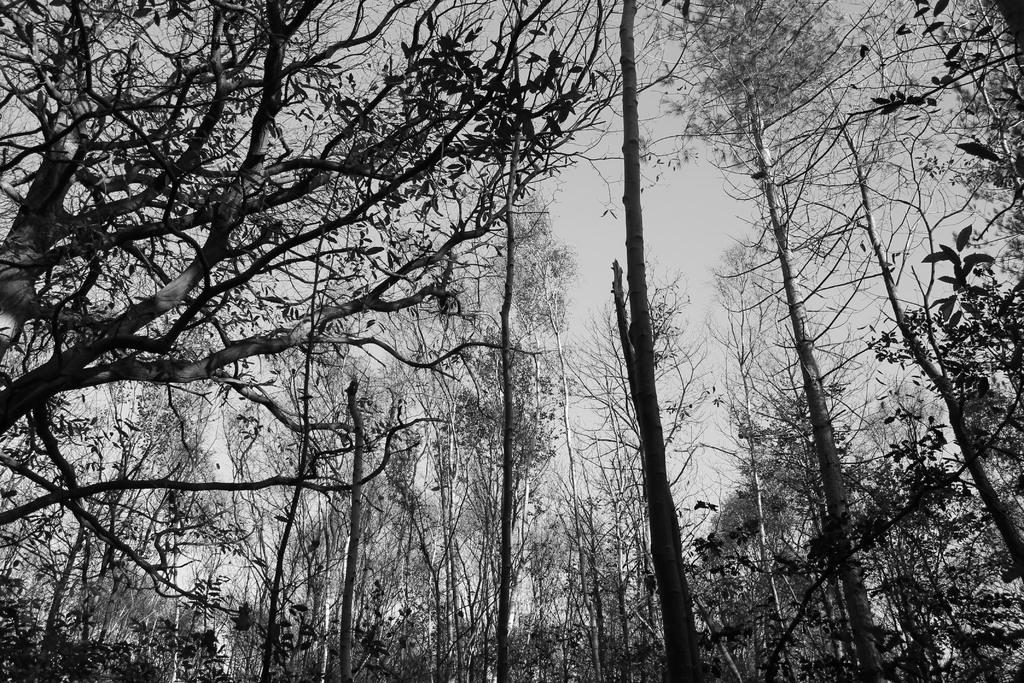What is the color scheme of the image? The image is black and white. What type of natural elements can be seen in the image? There are trees in the image. What is visible in the background of the image? The sky is visible in the background of the image. What type of committee is meeting in the image? There is no committee present in the image; it is a black and white image featuring trees and the sky. Can you tell me the color of the jar in the image? There is no jar present in the image. 